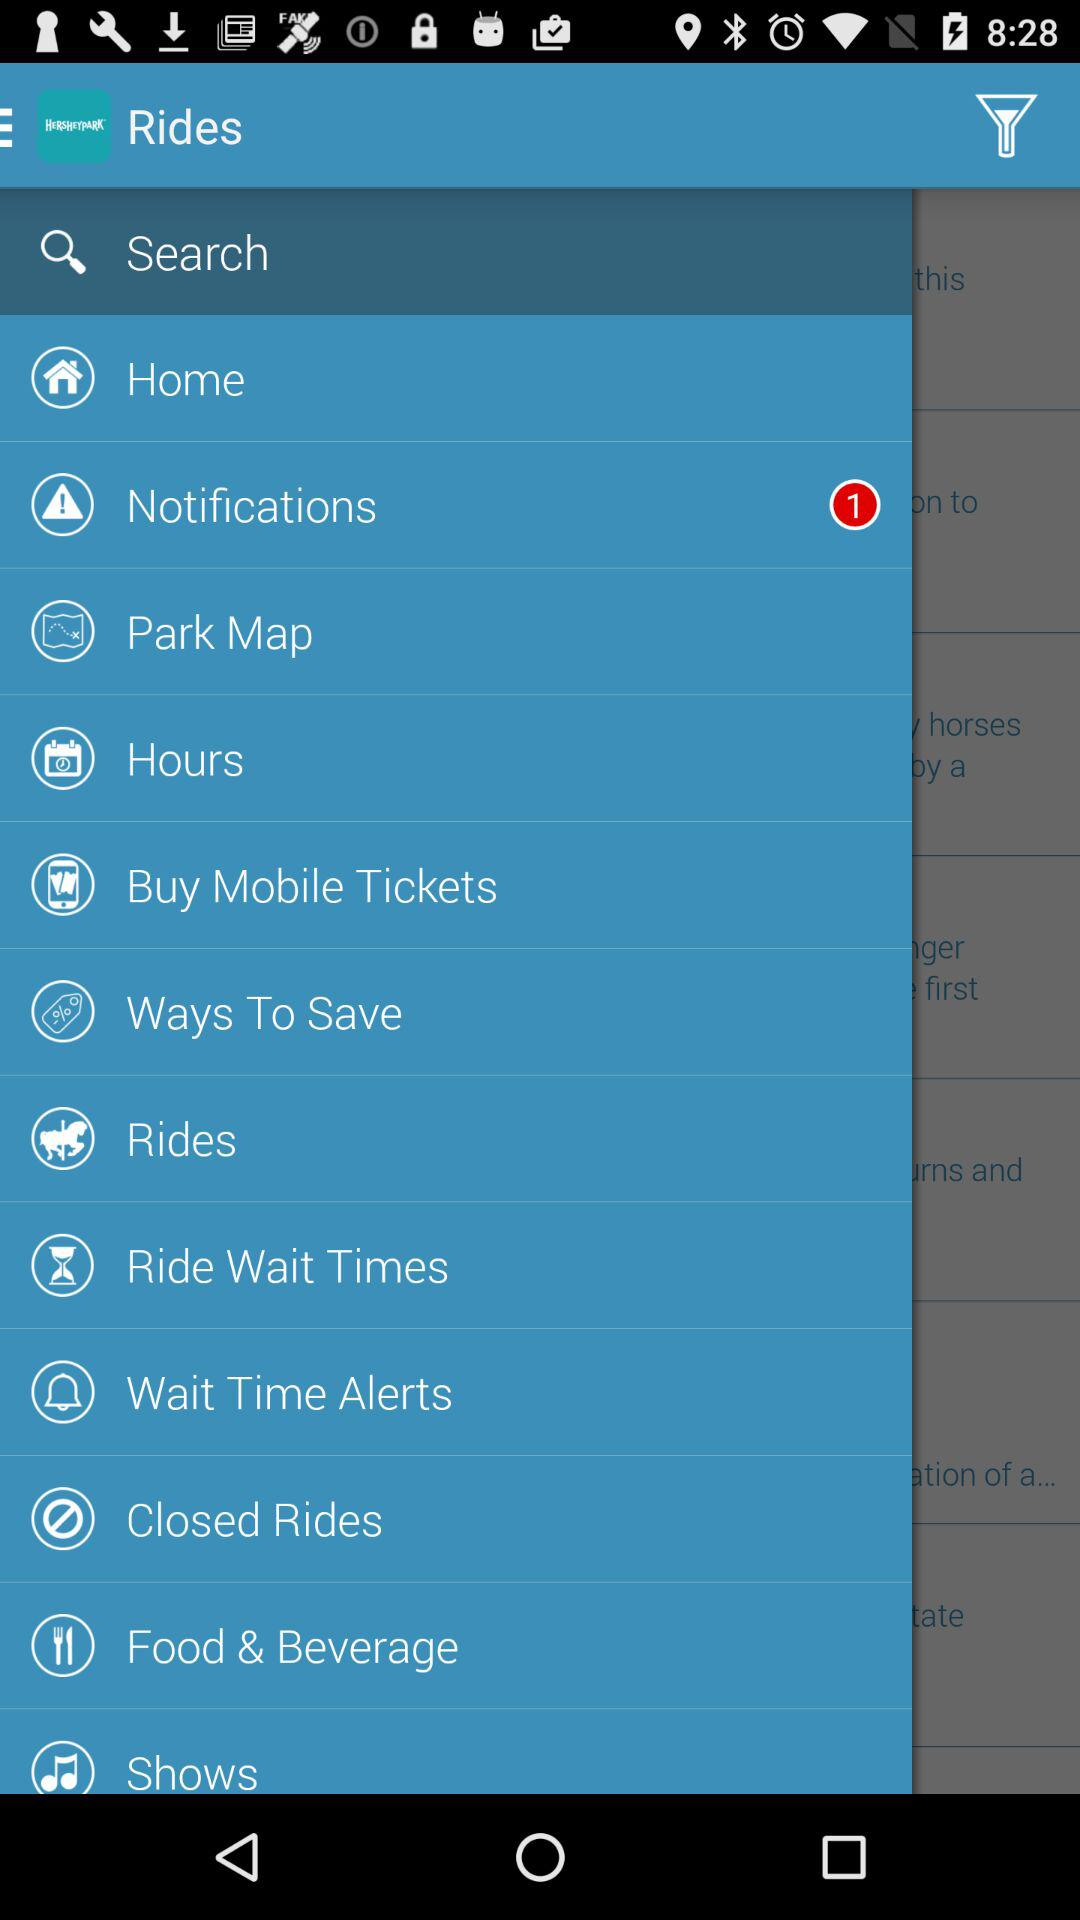How many notifications are there? There is 1 notification. 